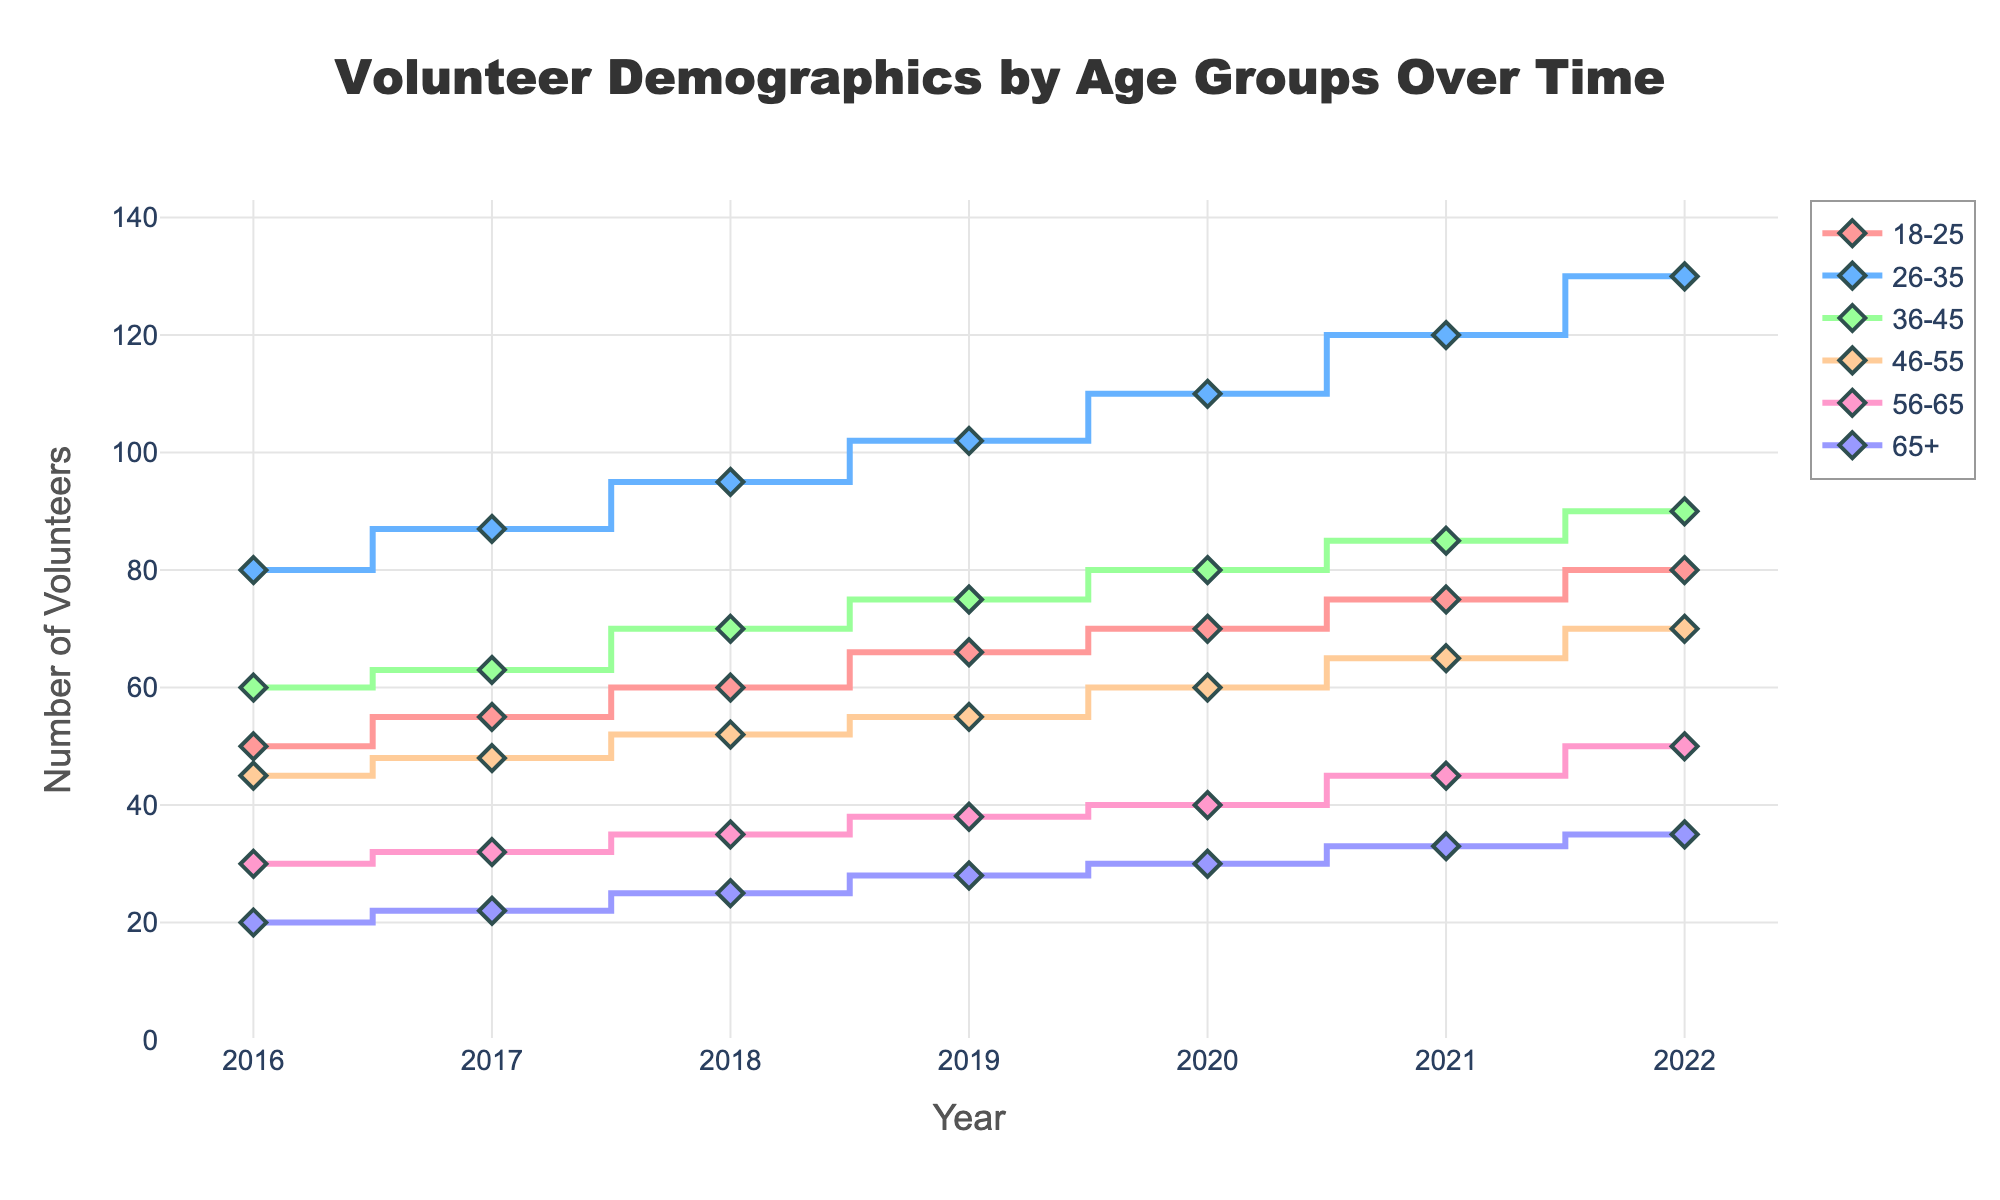What's the title of the figure? The title is written at the top center of the plot. It reads "Volunteer Demographics by Age Groups Over Time".
Answer: Volunteer Demographics by Age Groups Over Time How many age groups are tracked in the figure? The legend shows six different markers/colors corresponding to six age groups: 18-25, 26-35, 36-45, 46-55, 56-65, and 65+.
Answer: Six Which age group had the highest number of volunteers in 2022? By looking at the highest point on the graph for 2022, we can see that "26-35" has the highest value.
Answer: 26-35 By how much did the number of volunteers aged 18-25 increase from 2016 to 2022? The initial value in 2016 is 50 volunteers and the final value in 2022 is 80 volunteers. The increase is 80 - 50.
Answer: 30 Which age group has shown a consistent and steady rise over the years? Examining the lines, we find that "26-35" shows a consistent and steady upward trend each year.
Answer: 26-35 What was the total number of volunteers across all age groups in the year 2020? Adding the values for each age group in 2020: 70 + 110 + 80 + 60 + 40 + 30 = 390.
Answer: 390 Compare the volunteer numbers between 2016 and 2018 for the age group 46-55. Which year had more volunteers and by how much? In 2016, there were 45 volunteers, and in 2018, there were 52. The difference is 52 - 45.
Answer: 2018 by 7 Which age group had the smallest increase in the number of volunteers from 2016 to 2022? Calculating the differences for all age groups, "65+" increased from 20 to 35, which is the smallest increase of 15 volunteers.
Answer: 65+ What trend can be observed in the number of volunteers aged 56-65 from 2016 to 2022? The plot shows a gradual increase every year without any dips or drastic changes, indicating a steady upward trend.
Answer: Steady upward trend What was the average number of volunteers aged 36-45 over the given years? Add the yearly numbers for 36-45 from 2016 to 2022 and divide by the number of years (60+63+70+75+80+85+90) / 7 = 523 / 7 ≈ 74.71.
Answer: 74.71 